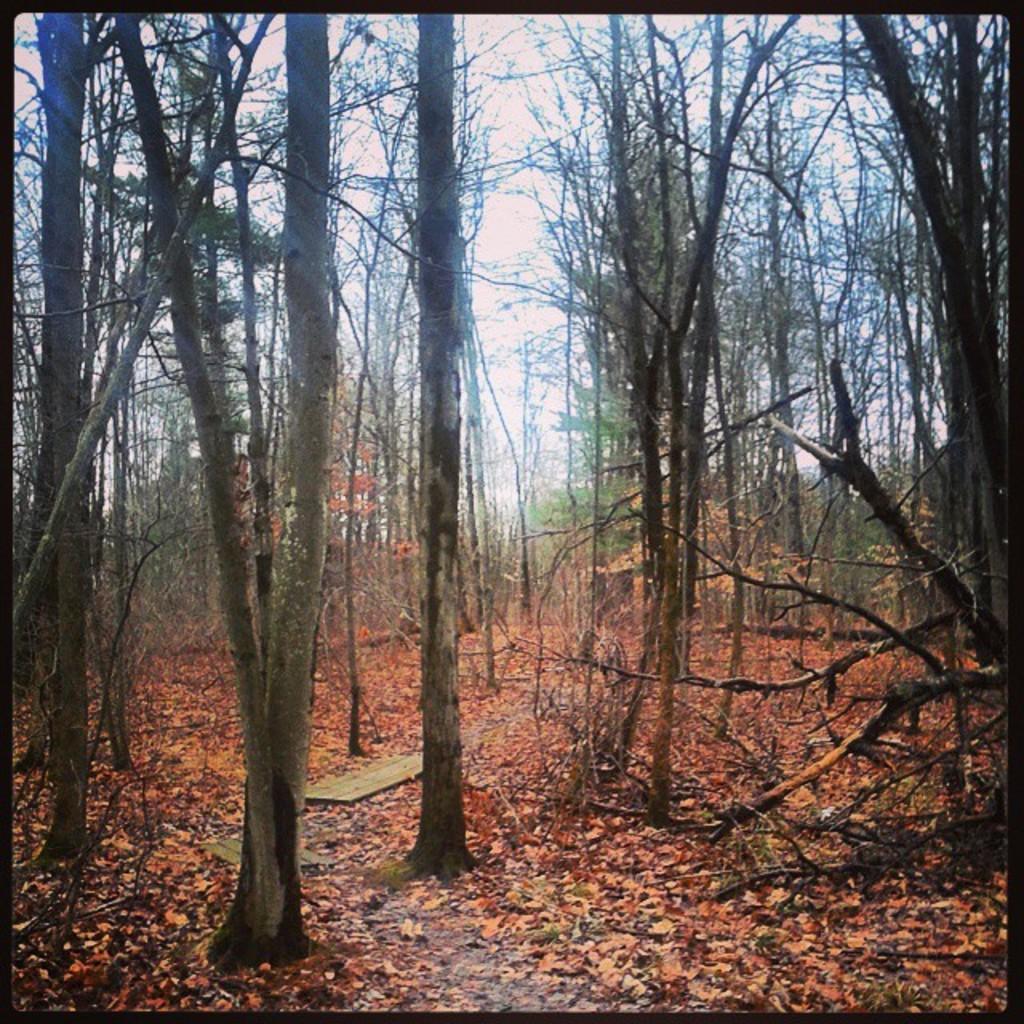Could you give a brief overview of what you see in this image? In this image we can see the trees and also the fallen leaves on the land. We can also see the sky and the image has borders. 